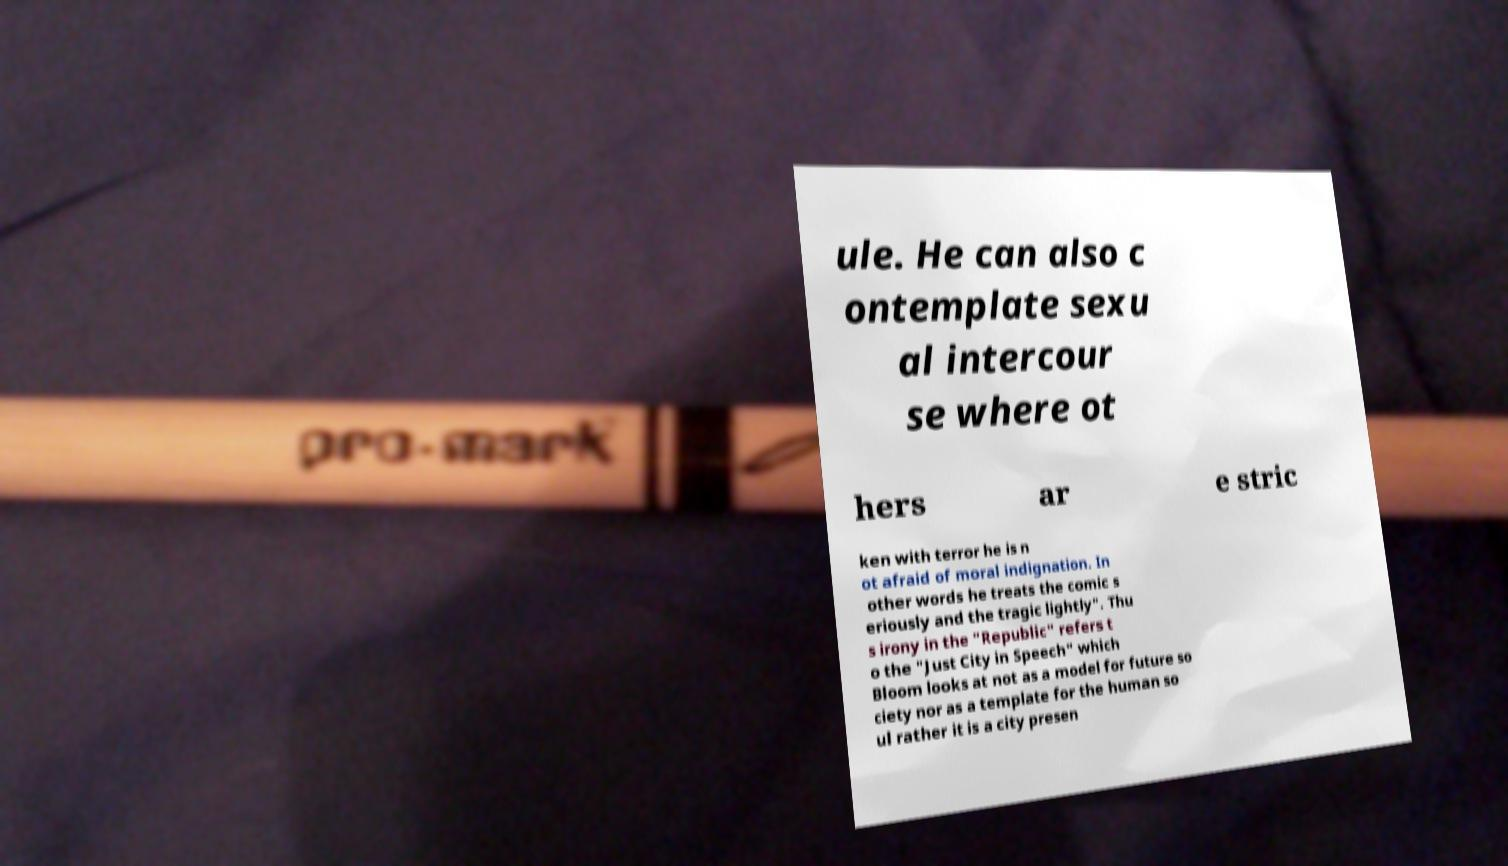Please read and relay the text visible in this image. What does it say? ule. He can also c ontemplate sexu al intercour se where ot hers ar e stric ken with terror he is n ot afraid of moral indignation. In other words he treats the comic s eriously and the tragic lightly". Thu s irony in the "Republic" refers t o the "Just City in Speech" which Bloom looks at not as a model for future so ciety nor as a template for the human so ul rather it is a city presen 